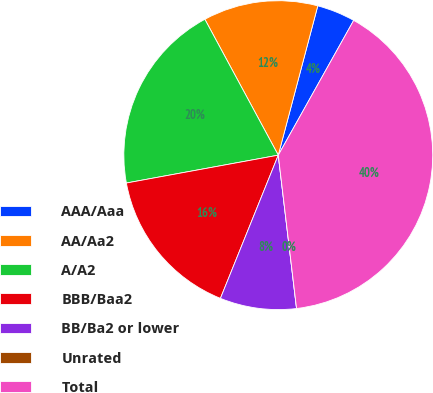Convert chart. <chart><loc_0><loc_0><loc_500><loc_500><pie_chart><fcel>AAA/Aaa<fcel>AA/Aa2<fcel>A/A2<fcel>BBB/Baa2<fcel>BB/Ba2 or lower<fcel>Unrated<fcel>Total<nl><fcel>4.0%<fcel>12.0%<fcel>20.0%<fcel>16.0%<fcel>8.0%<fcel>0.0%<fcel>39.99%<nl></chart> 